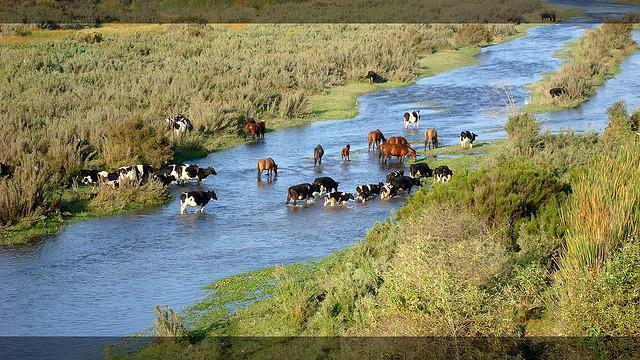How many people are on a horse?
Give a very brief answer. 0. 